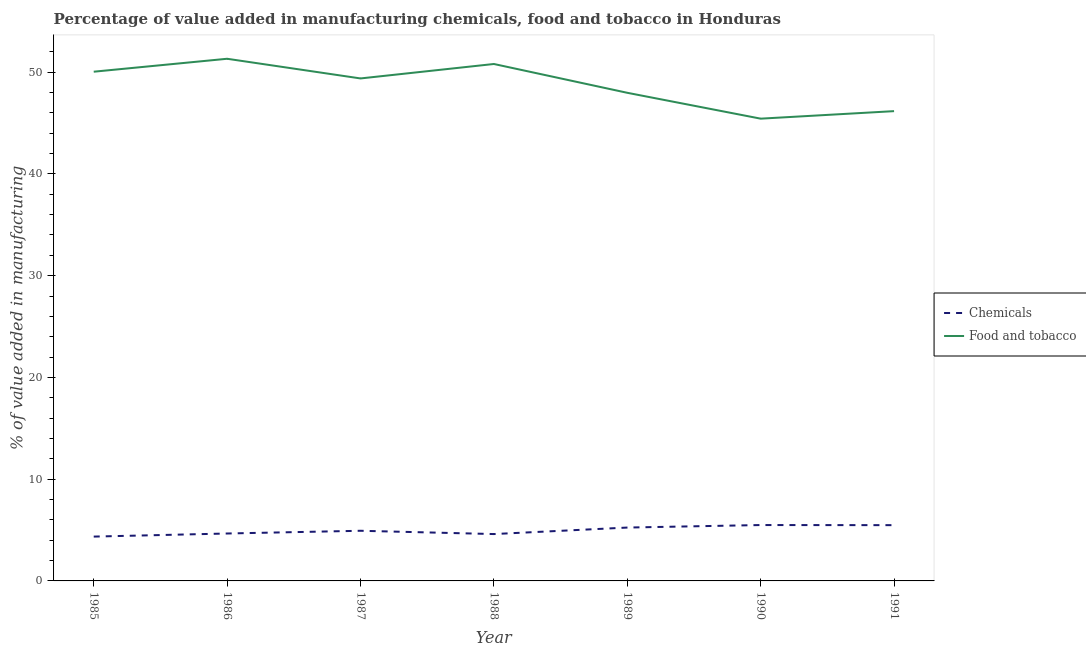How many different coloured lines are there?
Keep it short and to the point. 2. Is the number of lines equal to the number of legend labels?
Offer a very short reply. Yes. What is the value added by manufacturing food and tobacco in 1985?
Provide a short and direct response. 50.04. Across all years, what is the maximum value added by  manufacturing chemicals?
Provide a short and direct response. 5.49. Across all years, what is the minimum value added by manufacturing food and tobacco?
Keep it short and to the point. 45.43. In which year was the value added by  manufacturing chemicals minimum?
Your answer should be compact. 1985. What is the total value added by  manufacturing chemicals in the graph?
Ensure brevity in your answer.  34.77. What is the difference between the value added by  manufacturing chemicals in 1986 and that in 1991?
Offer a terse response. -0.82. What is the difference between the value added by manufacturing food and tobacco in 1986 and the value added by  manufacturing chemicals in 1988?
Make the answer very short. 46.71. What is the average value added by manufacturing food and tobacco per year?
Your answer should be compact. 48.73. In the year 1987, what is the difference between the value added by  manufacturing chemicals and value added by manufacturing food and tobacco?
Offer a very short reply. -44.45. In how many years, is the value added by manufacturing food and tobacco greater than 42 %?
Give a very brief answer. 7. What is the ratio of the value added by manufacturing food and tobacco in 1985 to that in 1987?
Ensure brevity in your answer.  1.01. Is the value added by  manufacturing chemicals in 1985 less than that in 1990?
Offer a very short reply. Yes. Is the difference between the value added by manufacturing food and tobacco in 1986 and 1991 greater than the difference between the value added by  manufacturing chemicals in 1986 and 1991?
Offer a terse response. Yes. What is the difference between the highest and the second highest value added by  manufacturing chemicals?
Give a very brief answer. 0.01. What is the difference between the highest and the lowest value added by  manufacturing chemicals?
Ensure brevity in your answer.  1.14. How many years are there in the graph?
Your answer should be very brief. 7. Does the graph contain any zero values?
Your answer should be compact. No. Where does the legend appear in the graph?
Provide a succinct answer. Center right. What is the title of the graph?
Your response must be concise. Percentage of value added in manufacturing chemicals, food and tobacco in Honduras. What is the label or title of the Y-axis?
Your response must be concise. % of value added in manufacturing. What is the % of value added in manufacturing of Chemicals in 1985?
Offer a terse response. 4.36. What is the % of value added in manufacturing of Food and tobacco in 1985?
Offer a very short reply. 50.04. What is the % of value added in manufacturing of Chemicals in 1986?
Offer a terse response. 4.66. What is the % of value added in manufacturing of Food and tobacco in 1986?
Ensure brevity in your answer.  51.32. What is the % of value added in manufacturing in Chemicals in 1987?
Make the answer very short. 4.93. What is the % of value added in manufacturing of Food and tobacco in 1987?
Provide a succinct answer. 49.38. What is the % of value added in manufacturing of Chemicals in 1988?
Provide a short and direct response. 4.61. What is the % of value added in manufacturing of Food and tobacco in 1988?
Give a very brief answer. 50.8. What is the % of value added in manufacturing in Chemicals in 1989?
Your response must be concise. 5.24. What is the % of value added in manufacturing in Food and tobacco in 1989?
Provide a short and direct response. 47.97. What is the % of value added in manufacturing of Chemicals in 1990?
Give a very brief answer. 5.49. What is the % of value added in manufacturing of Food and tobacco in 1990?
Your answer should be compact. 45.43. What is the % of value added in manufacturing in Chemicals in 1991?
Make the answer very short. 5.48. What is the % of value added in manufacturing of Food and tobacco in 1991?
Make the answer very short. 46.17. Across all years, what is the maximum % of value added in manufacturing of Chemicals?
Ensure brevity in your answer.  5.49. Across all years, what is the maximum % of value added in manufacturing of Food and tobacco?
Your answer should be compact. 51.32. Across all years, what is the minimum % of value added in manufacturing of Chemicals?
Your response must be concise. 4.36. Across all years, what is the minimum % of value added in manufacturing of Food and tobacco?
Your answer should be compact. 45.43. What is the total % of value added in manufacturing in Chemicals in the graph?
Make the answer very short. 34.77. What is the total % of value added in manufacturing of Food and tobacco in the graph?
Give a very brief answer. 341.12. What is the difference between the % of value added in manufacturing in Chemicals in 1985 and that in 1986?
Offer a terse response. -0.3. What is the difference between the % of value added in manufacturing of Food and tobacco in 1985 and that in 1986?
Offer a very short reply. -1.27. What is the difference between the % of value added in manufacturing in Chemicals in 1985 and that in 1987?
Ensure brevity in your answer.  -0.57. What is the difference between the % of value added in manufacturing of Food and tobacco in 1985 and that in 1987?
Give a very brief answer. 0.66. What is the difference between the % of value added in manufacturing in Chemicals in 1985 and that in 1988?
Provide a succinct answer. -0.25. What is the difference between the % of value added in manufacturing of Food and tobacco in 1985 and that in 1988?
Give a very brief answer. -0.76. What is the difference between the % of value added in manufacturing in Chemicals in 1985 and that in 1989?
Offer a terse response. -0.89. What is the difference between the % of value added in manufacturing in Food and tobacco in 1985 and that in 1989?
Your answer should be compact. 2.07. What is the difference between the % of value added in manufacturing of Chemicals in 1985 and that in 1990?
Give a very brief answer. -1.14. What is the difference between the % of value added in manufacturing of Food and tobacco in 1985 and that in 1990?
Provide a short and direct response. 4.61. What is the difference between the % of value added in manufacturing in Chemicals in 1985 and that in 1991?
Your answer should be very brief. -1.12. What is the difference between the % of value added in manufacturing in Food and tobacco in 1985 and that in 1991?
Provide a short and direct response. 3.88. What is the difference between the % of value added in manufacturing of Chemicals in 1986 and that in 1987?
Make the answer very short. -0.27. What is the difference between the % of value added in manufacturing of Food and tobacco in 1986 and that in 1987?
Offer a very short reply. 1.93. What is the difference between the % of value added in manufacturing in Chemicals in 1986 and that in 1988?
Your response must be concise. 0.06. What is the difference between the % of value added in manufacturing of Food and tobacco in 1986 and that in 1988?
Your answer should be very brief. 0.51. What is the difference between the % of value added in manufacturing of Chemicals in 1986 and that in 1989?
Ensure brevity in your answer.  -0.58. What is the difference between the % of value added in manufacturing of Food and tobacco in 1986 and that in 1989?
Ensure brevity in your answer.  3.34. What is the difference between the % of value added in manufacturing in Chemicals in 1986 and that in 1990?
Your answer should be compact. -0.83. What is the difference between the % of value added in manufacturing of Food and tobacco in 1986 and that in 1990?
Make the answer very short. 5.89. What is the difference between the % of value added in manufacturing in Chemicals in 1986 and that in 1991?
Offer a terse response. -0.82. What is the difference between the % of value added in manufacturing of Food and tobacco in 1986 and that in 1991?
Provide a succinct answer. 5.15. What is the difference between the % of value added in manufacturing of Chemicals in 1987 and that in 1988?
Provide a short and direct response. 0.32. What is the difference between the % of value added in manufacturing of Food and tobacco in 1987 and that in 1988?
Give a very brief answer. -1.42. What is the difference between the % of value added in manufacturing in Chemicals in 1987 and that in 1989?
Offer a very short reply. -0.32. What is the difference between the % of value added in manufacturing in Food and tobacco in 1987 and that in 1989?
Make the answer very short. 1.41. What is the difference between the % of value added in manufacturing in Chemicals in 1987 and that in 1990?
Ensure brevity in your answer.  -0.56. What is the difference between the % of value added in manufacturing of Food and tobacco in 1987 and that in 1990?
Offer a terse response. 3.95. What is the difference between the % of value added in manufacturing in Chemicals in 1987 and that in 1991?
Offer a terse response. -0.55. What is the difference between the % of value added in manufacturing of Food and tobacco in 1987 and that in 1991?
Keep it short and to the point. 3.21. What is the difference between the % of value added in manufacturing in Chemicals in 1988 and that in 1989?
Provide a succinct answer. -0.64. What is the difference between the % of value added in manufacturing in Food and tobacco in 1988 and that in 1989?
Ensure brevity in your answer.  2.83. What is the difference between the % of value added in manufacturing of Chemicals in 1988 and that in 1990?
Offer a terse response. -0.89. What is the difference between the % of value added in manufacturing in Food and tobacco in 1988 and that in 1990?
Your answer should be compact. 5.37. What is the difference between the % of value added in manufacturing of Chemicals in 1988 and that in 1991?
Provide a succinct answer. -0.87. What is the difference between the % of value added in manufacturing in Food and tobacco in 1988 and that in 1991?
Your answer should be very brief. 4.63. What is the difference between the % of value added in manufacturing of Chemicals in 1989 and that in 1990?
Offer a very short reply. -0.25. What is the difference between the % of value added in manufacturing of Food and tobacco in 1989 and that in 1990?
Offer a terse response. 2.54. What is the difference between the % of value added in manufacturing in Chemicals in 1989 and that in 1991?
Your answer should be compact. -0.24. What is the difference between the % of value added in manufacturing in Food and tobacco in 1989 and that in 1991?
Give a very brief answer. 1.8. What is the difference between the % of value added in manufacturing of Chemicals in 1990 and that in 1991?
Give a very brief answer. 0.01. What is the difference between the % of value added in manufacturing of Food and tobacco in 1990 and that in 1991?
Ensure brevity in your answer.  -0.74. What is the difference between the % of value added in manufacturing in Chemicals in 1985 and the % of value added in manufacturing in Food and tobacco in 1986?
Your response must be concise. -46.96. What is the difference between the % of value added in manufacturing of Chemicals in 1985 and the % of value added in manufacturing of Food and tobacco in 1987?
Offer a terse response. -45.03. What is the difference between the % of value added in manufacturing in Chemicals in 1985 and the % of value added in manufacturing in Food and tobacco in 1988?
Your response must be concise. -46.45. What is the difference between the % of value added in manufacturing of Chemicals in 1985 and the % of value added in manufacturing of Food and tobacco in 1989?
Provide a short and direct response. -43.62. What is the difference between the % of value added in manufacturing in Chemicals in 1985 and the % of value added in manufacturing in Food and tobacco in 1990?
Your answer should be very brief. -41.07. What is the difference between the % of value added in manufacturing in Chemicals in 1985 and the % of value added in manufacturing in Food and tobacco in 1991?
Give a very brief answer. -41.81. What is the difference between the % of value added in manufacturing in Chemicals in 1986 and the % of value added in manufacturing in Food and tobacco in 1987?
Ensure brevity in your answer.  -44.72. What is the difference between the % of value added in manufacturing of Chemicals in 1986 and the % of value added in manufacturing of Food and tobacco in 1988?
Keep it short and to the point. -46.14. What is the difference between the % of value added in manufacturing of Chemicals in 1986 and the % of value added in manufacturing of Food and tobacco in 1989?
Make the answer very short. -43.31. What is the difference between the % of value added in manufacturing of Chemicals in 1986 and the % of value added in manufacturing of Food and tobacco in 1990?
Your answer should be very brief. -40.77. What is the difference between the % of value added in manufacturing in Chemicals in 1986 and the % of value added in manufacturing in Food and tobacco in 1991?
Ensure brevity in your answer.  -41.51. What is the difference between the % of value added in manufacturing in Chemicals in 1987 and the % of value added in manufacturing in Food and tobacco in 1988?
Keep it short and to the point. -45.87. What is the difference between the % of value added in manufacturing in Chemicals in 1987 and the % of value added in manufacturing in Food and tobacco in 1989?
Your response must be concise. -43.04. What is the difference between the % of value added in manufacturing of Chemicals in 1987 and the % of value added in manufacturing of Food and tobacco in 1990?
Keep it short and to the point. -40.5. What is the difference between the % of value added in manufacturing in Chemicals in 1987 and the % of value added in manufacturing in Food and tobacco in 1991?
Provide a succinct answer. -41.24. What is the difference between the % of value added in manufacturing in Chemicals in 1988 and the % of value added in manufacturing in Food and tobacco in 1989?
Make the answer very short. -43.37. What is the difference between the % of value added in manufacturing in Chemicals in 1988 and the % of value added in manufacturing in Food and tobacco in 1990?
Your answer should be very brief. -40.82. What is the difference between the % of value added in manufacturing of Chemicals in 1988 and the % of value added in manufacturing of Food and tobacco in 1991?
Your answer should be very brief. -41.56. What is the difference between the % of value added in manufacturing of Chemicals in 1989 and the % of value added in manufacturing of Food and tobacco in 1990?
Ensure brevity in your answer.  -40.19. What is the difference between the % of value added in manufacturing in Chemicals in 1989 and the % of value added in manufacturing in Food and tobacco in 1991?
Your answer should be compact. -40.92. What is the difference between the % of value added in manufacturing in Chemicals in 1990 and the % of value added in manufacturing in Food and tobacco in 1991?
Give a very brief answer. -40.68. What is the average % of value added in manufacturing in Chemicals per year?
Your answer should be compact. 4.97. What is the average % of value added in manufacturing in Food and tobacco per year?
Your answer should be very brief. 48.73. In the year 1985, what is the difference between the % of value added in manufacturing of Chemicals and % of value added in manufacturing of Food and tobacco?
Offer a very short reply. -45.69. In the year 1986, what is the difference between the % of value added in manufacturing of Chemicals and % of value added in manufacturing of Food and tobacco?
Keep it short and to the point. -46.66. In the year 1987, what is the difference between the % of value added in manufacturing in Chemicals and % of value added in manufacturing in Food and tobacco?
Offer a very short reply. -44.45. In the year 1988, what is the difference between the % of value added in manufacturing of Chemicals and % of value added in manufacturing of Food and tobacco?
Your response must be concise. -46.2. In the year 1989, what is the difference between the % of value added in manufacturing of Chemicals and % of value added in manufacturing of Food and tobacco?
Keep it short and to the point. -42.73. In the year 1990, what is the difference between the % of value added in manufacturing in Chemicals and % of value added in manufacturing in Food and tobacco?
Your answer should be very brief. -39.94. In the year 1991, what is the difference between the % of value added in manufacturing of Chemicals and % of value added in manufacturing of Food and tobacco?
Provide a short and direct response. -40.69. What is the ratio of the % of value added in manufacturing in Chemicals in 1985 to that in 1986?
Offer a terse response. 0.93. What is the ratio of the % of value added in manufacturing in Food and tobacco in 1985 to that in 1986?
Give a very brief answer. 0.98. What is the ratio of the % of value added in manufacturing in Chemicals in 1985 to that in 1987?
Make the answer very short. 0.88. What is the ratio of the % of value added in manufacturing of Food and tobacco in 1985 to that in 1987?
Your response must be concise. 1.01. What is the ratio of the % of value added in manufacturing in Chemicals in 1985 to that in 1988?
Offer a very short reply. 0.95. What is the ratio of the % of value added in manufacturing in Food and tobacco in 1985 to that in 1988?
Your answer should be very brief. 0.99. What is the ratio of the % of value added in manufacturing of Chemicals in 1985 to that in 1989?
Provide a short and direct response. 0.83. What is the ratio of the % of value added in manufacturing in Food and tobacco in 1985 to that in 1989?
Your answer should be very brief. 1.04. What is the ratio of the % of value added in manufacturing in Chemicals in 1985 to that in 1990?
Your answer should be very brief. 0.79. What is the ratio of the % of value added in manufacturing in Food and tobacco in 1985 to that in 1990?
Your answer should be compact. 1.1. What is the ratio of the % of value added in manufacturing of Chemicals in 1985 to that in 1991?
Make the answer very short. 0.79. What is the ratio of the % of value added in manufacturing in Food and tobacco in 1985 to that in 1991?
Your answer should be very brief. 1.08. What is the ratio of the % of value added in manufacturing of Chemicals in 1986 to that in 1987?
Provide a succinct answer. 0.95. What is the ratio of the % of value added in manufacturing of Food and tobacco in 1986 to that in 1987?
Your response must be concise. 1.04. What is the ratio of the % of value added in manufacturing of Chemicals in 1986 to that in 1988?
Your response must be concise. 1.01. What is the ratio of the % of value added in manufacturing in Chemicals in 1986 to that in 1989?
Keep it short and to the point. 0.89. What is the ratio of the % of value added in manufacturing in Food and tobacco in 1986 to that in 1989?
Keep it short and to the point. 1.07. What is the ratio of the % of value added in manufacturing of Chemicals in 1986 to that in 1990?
Keep it short and to the point. 0.85. What is the ratio of the % of value added in manufacturing of Food and tobacco in 1986 to that in 1990?
Provide a succinct answer. 1.13. What is the ratio of the % of value added in manufacturing in Chemicals in 1986 to that in 1991?
Ensure brevity in your answer.  0.85. What is the ratio of the % of value added in manufacturing of Food and tobacco in 1986 to that in 1991?
Provide a short and direct response. 1.11. What is the ratio of the % of value added in manufacturing of Chemicals in 1987 to that in 1988?
Ensure brevity in your answer.  1.07. What is the ratio of the % of value added in manufacturing of Food and tobacco in 1987 to that in 1988?
Provide a short and direct response. 0.97. What is the ratio of the % of value added in manufacturing of Chemicals in 1987 to that in 1989?
Ensure brevity in your answer.  0.94. What is the ratio of the % of value added in manufacturing in Food and tobacco in 1987 to that in 1989?
Give a very brief answer. 1.03. What is the ratio of the % of value added in manufacturing in Chemicals in 1987 to that in 1990?
Keep it short and to the point. 0.9. What is the ratio of the % of value added in manufacturing of Food and tobacco in 1987 to that in 1990?
Offer a very short reply. 1.09. What is the ratio of the % of value added in manufacturing of Chemicals in 1987 to that in 1991?
Your response must be concise. 0.9. What is the ratio of the % of value added in manufacturing in Food and tobacco in 1987 to that in 1991?
Ensure brevity in your answer.  1.07. What is the ratio of the % of value added in manufacturing in Chemicals in 1988 to that in 1989?
Ensure brevity in your answer.  0.88. What is the ratio of the % of value added in manufacturing in Food and tobacco in 1988 to that in 1989?
Make the answer very short. 1.06. What is the ratio of the % of value added in manufacturing of Chemicals in 1988 to that in 1990?
Keep it short and to the point. 0.84. What is the ratio of the % of value added in manufacturing of Food and tobacco in 1988 to that in 1990?
Ensure brevity in your answer.  1.12. What is the ratio of the % of value added in manufacturing in Chemicals in 1988 to that in 1991?
Give a very brief answer. 0.84. What is the ratio of the % of value added in manufacturing of Food and tobacco in 1988 to that in 1991?
Provide a short and direct response. 1.1. What is the ratio of the % of value added in manufacturing of Chemicals in 1989 to that in 1990?
Provide a succinct answer. 0.95. What is the ratio of the % of value added in manufacturing of Food and tobacco in 1989 to that in 1990?
Your answer should be very brief. 1.06. What is the ratio of the % of value added in manufacturing in Chemicals in 1989 to that in 1991?
Provide a short and direct response. 0.96. What is the ratio of the % of value added in manufacturing in Food and tobacco in 1989 to that in 1991?
Ensure brevity in your answer.  1.04. What is the difference between the highest and the second highest % of value added in manufacturing of Chemicals?
Your response must be concise. 0.01. What is the difference between the highest and the second highest % of value added in manufacturing of Food and tobacco?
Ensure brevity in your answer.  0.51. What is the difference between the highest and the lowest % of value added in manufacturing in Chemicals?
Make the answer very short. 1.14. What is the difference between the highest and the lowest % of value added in manufacturing in Food and tobacco?
Ensure brevity in your answer.  5.89. 